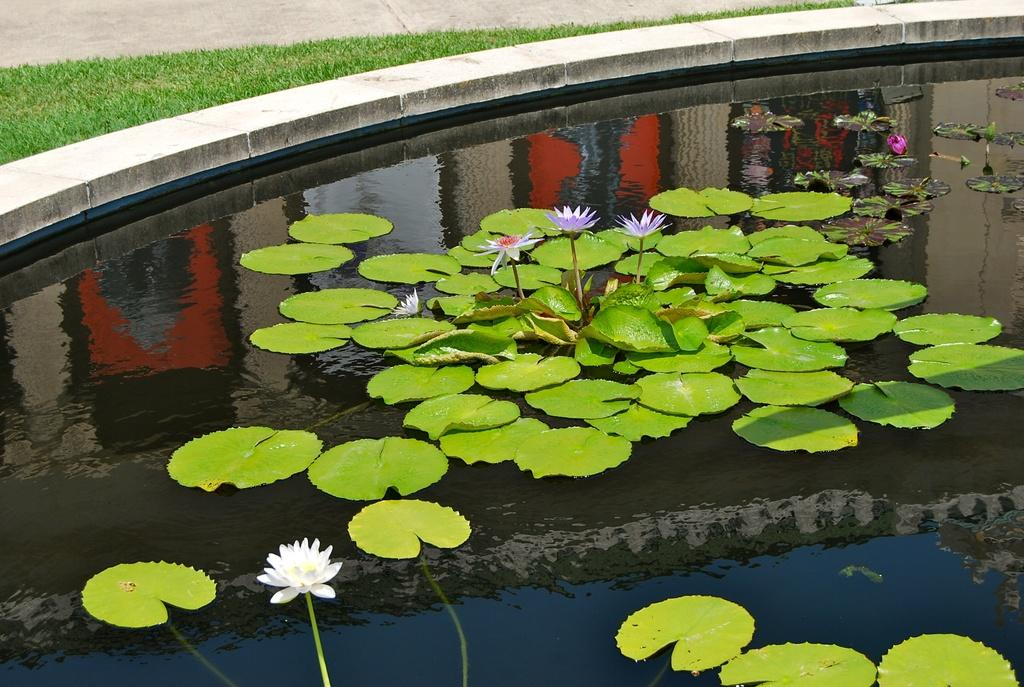What type of plant is featured in the image? There are lotus in the image. What part of the lotus plant is also visible? There are lotus leaves in the image. Where are the lotus and lotus leaves located? The lotus and lotus leaves are in a pond. What type of vegetation can be seen in the image besides the lotus and lotus leaves? There is grass visible in the image. How many spies are hiding among the lotus leaves in the image? There are no spies present in the image; it features lotus and lotus leaves in a pond. 